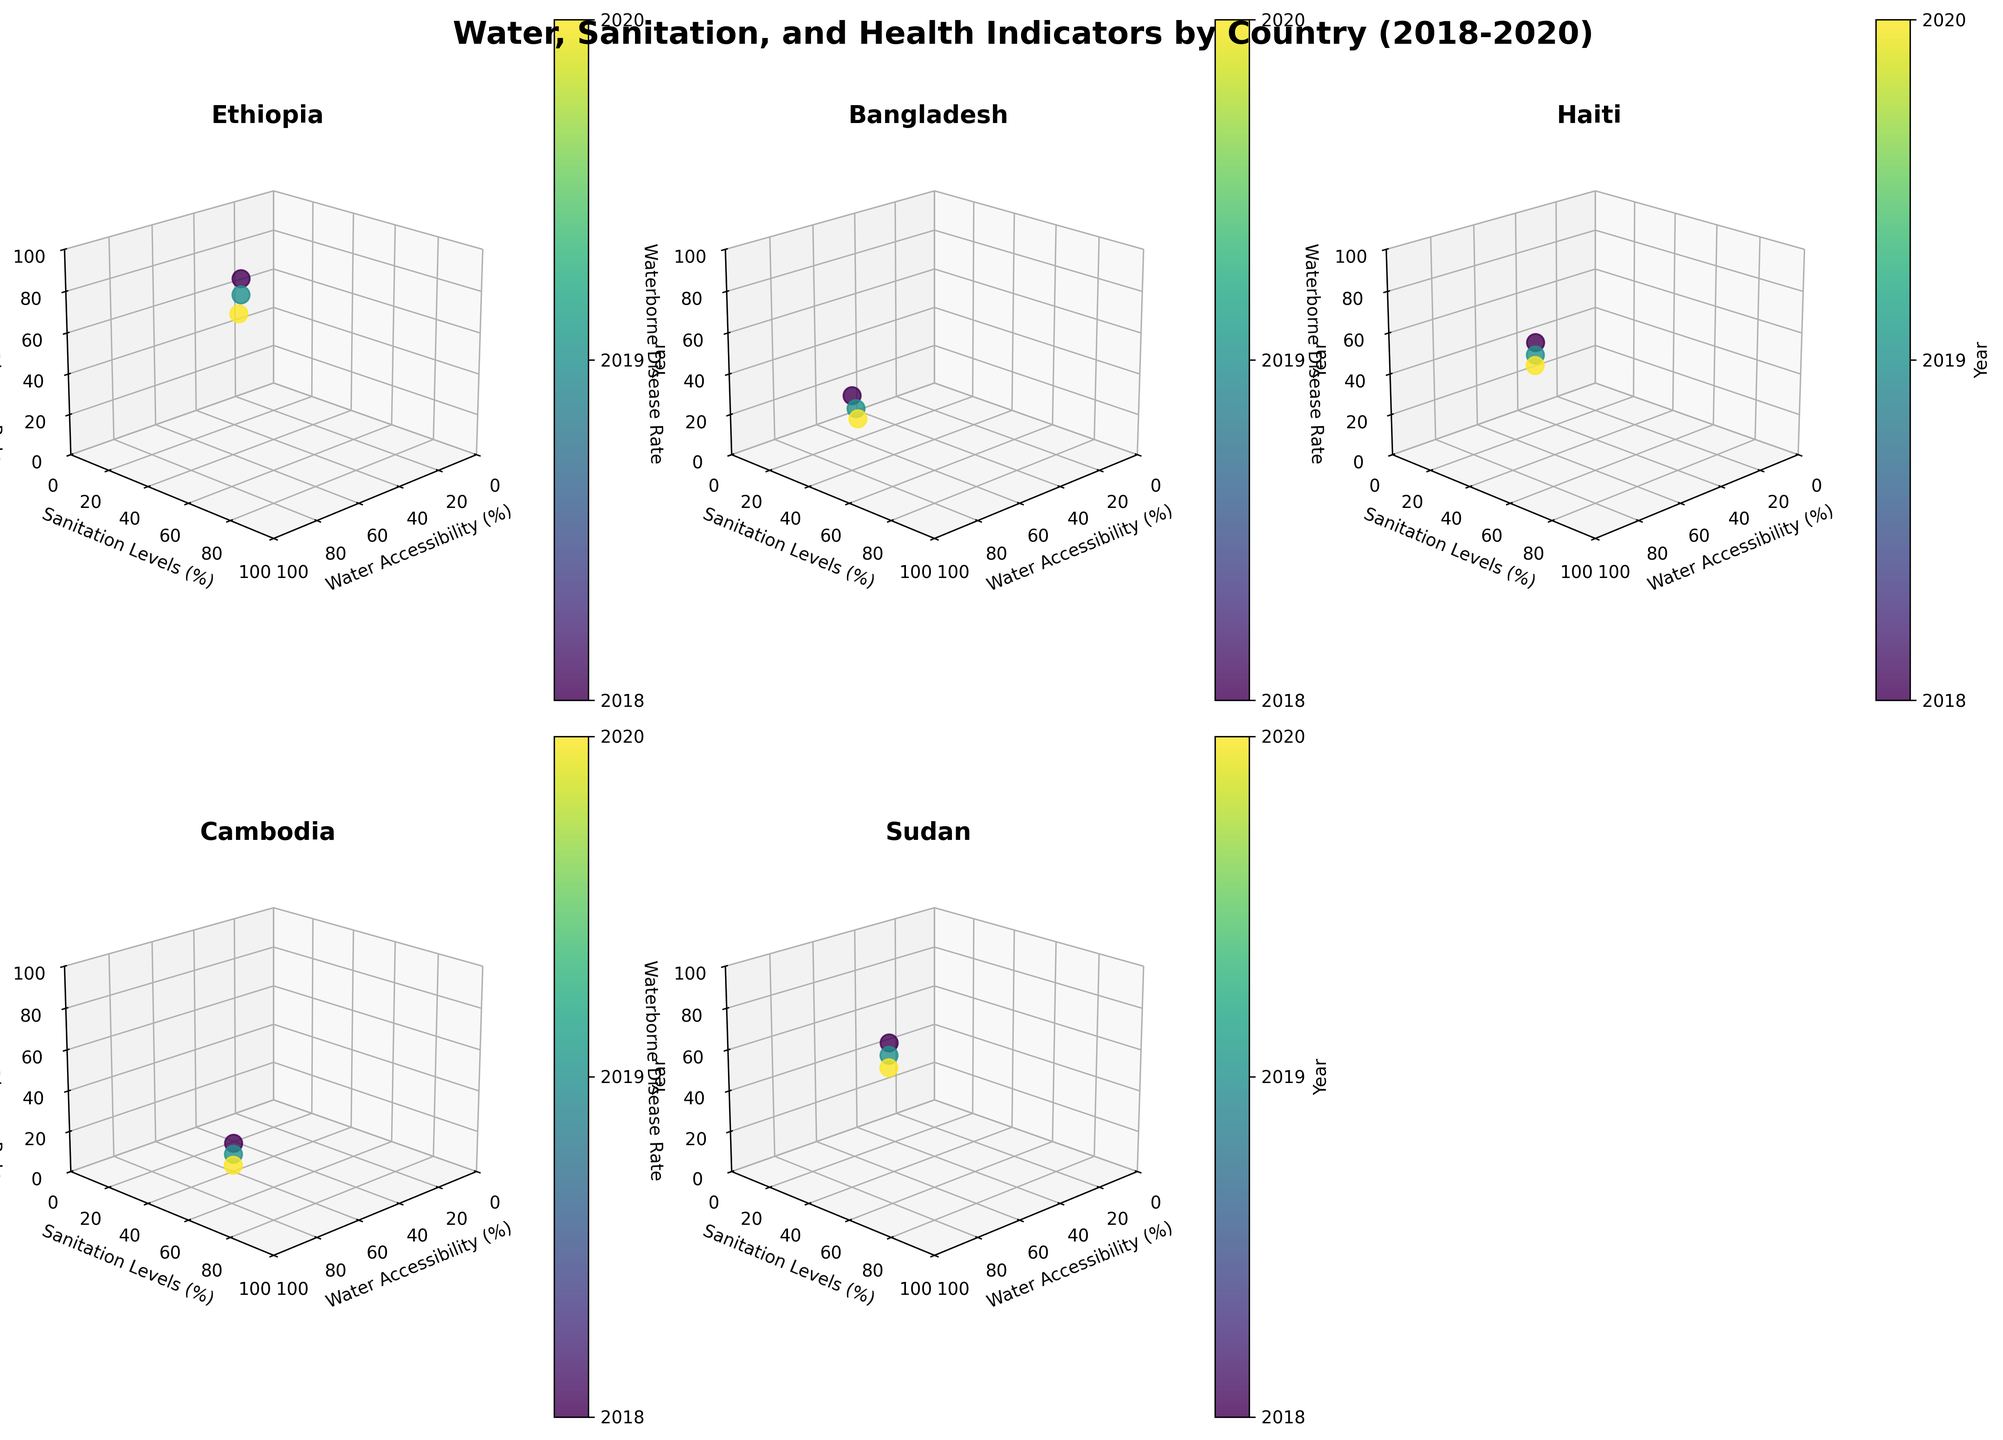How many countries are analyzed in the figure? By counting the number of subplots, we can determine the number of countries analyzed. There are six subplots corresponding to six different countries.
Answer: 6 Which country has the highest overall water accessibility in 2020? By examining the axis labeled 'Water Accessibility (%)' for each subplot, we notice that Cambodia has the highest point on the x-axis in 2020.
Answer: Cambodia In which year did Sudan have the lowest waterborne disease rate? By looking at the colors in the Sudan subplot, we can identify the year corresponding to the lowest point on the z-axis. The lowest waterborne disease rate for Sudan is in 2020.
Answer: 2020 What's the average water accessibility percentage for Haiti between 2018 and 2020? For Haiti, we add the water accessibility percentages for the three years (64+67+70) and divide by 3. (64+67+70)/3 = 67
Answer: 67 Compare the trend in sanitation levels for Ethiopia and Bangladesh between 2018 and 2020. Which country shows a greater improvement? By examining the y-axis for both subplots, we calculate the increase in sanitation levels. Ethiopia's levels increased from 29% to 35% (a 6% increase), and Bangladesh's levels increased from 48% to 55% (a 7% increase). Therefore, Bangladesh shows a greater improvement.
Answer: Bangladesh Which country shows the most significant decrease in waterborne disease rates from 2018 to 2020? By looking at the trends along the z-axis, Ethiopia's waterborne disease rate decreases from 78 to 65 (a 13-point drop), which is the most significant decrease among the countries shown.
Answer: Ethiopia What is the relationship between water accessibility and sanitation levels for Cambodia in 2019? For Cambodia in 2019, we identify the respective data points on the x and y axes. Water accessibility is 81% and sanitation levels are 62%.
Answer: Water Accessibility: 81%, Sanitation Levels: 62% Between Ethiopia and Sudan, which country had a higher average waterborne disease rate for the years 2018-2020? We calculate the average waterborne disease rate for both countries over the three years. Ethiopia: (78+72+65)/3 = 71.67 and Sudan: (62+58+54)/3 = 58. Therefore, Ethiopia had a higher average rate.
Answer: Ethiopia What trend can be observed in Bangladesh regarding water accessibility from 2018 to 2020? By looking at the x-axis in the Bangladesh subplot, we can see an upward trend in water accessibility from 87% in 2018 to 91% in 2020.
Answer: Increasing 